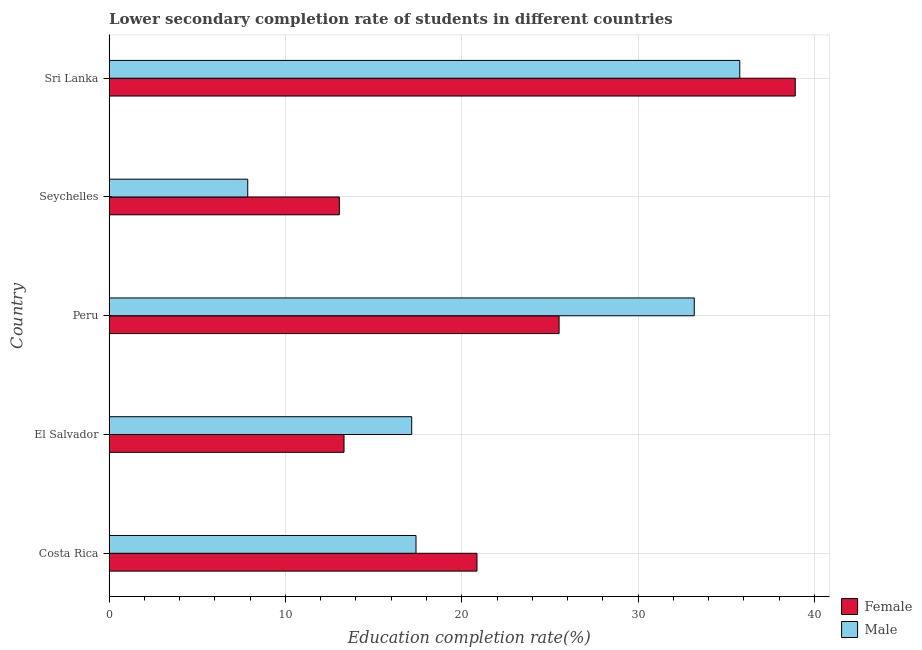How many groups of bars are there?
Your response must be concise. 5. Are the number of bars per tick equal to the number of legend labels?
Your answer should be compact. Yes. Are the number of bars on each tick of the Y-axis equal?
Offer a terse response. Yes. How many bars are there on the 3rd tick from the top?
Make the answer very short. 2. How many bars are there on the 5th tick from the bottom?
Your answer should be very brief. 2. What is the label of the 4th group of bars from the top?
Offer a terse response. El Salvador. What is the education completion rate of male students in Costa Rica?
Your answer should be very brief. 17.41. Across all countries, what is the maximum education completion rate of female students?
Offer a very short reply. 38.91. Across all countries, what is the minimum education completion rate of female students?
Ensure brevity in your answer.  13.06. In which country was the education completion rate of female students maximum?
Provide a short and direct response. Sri Lanka. In which country was the education completion rate of male students minimum?
Your response must be concise. Seychelles. What is the total education completion rate of male students in the graph?
Ensure brevity in your answer.  111.37. What is the difference between the education completion rate of male students in El Salvador and that in Seychelles?
Give a very brief answer. 9.3. What is the difference between the education completion rate of male students in Seychelles and the education completion rate of female students in Sri Lanka?
Your answer should be compact. -31.04. What is the average education completion rate of female students per country?
Keep it short and to the point. 22.33. What is the difference between the education completion rate of female students and education completion rate of male students in Peru?
Your answer should be very brief. -7.66. In how many countries, is the education completion rate of male students greater than 18 %?
Give a very brief answer. 2. What is the ratio of the education completion rate of female students in El Salvador to that in Sri Lanka?
Provide a succinct answer. 0.34. Is the education completion rate of female students in Costa Rica less than that in El Salvador?
Your answer should be very brief. No. Is the difference between the education completion rate of male students in Costa Rica and Seychelles greater than the difference between the education completion rate of female students in Costa Rica and Seychelles?
Give a very brief answer. Yes. What is the difference between the highest and the second highest education completion rate of male students?
Ensure brevity in your answer.  2.58. What is the difference between the highest and the lowest education completion rate of female students?
Keep it short and to the point. 25.85. Is the sum of the education completion rate of male students in Costa Rica and El Salvador greater than the maximum education completion rate of female students across all countries?
Ensure brevity in your answer.  No. What does the 1st bar from the top in Seychelles represents?
Provide a succinct answer. Male. What does the 1st bar from the bottom in Peru represents?
Offer a terse response. Female. How many bars are there?
Provide a short and direct response. 10. What is the difference between two consecutive major ticks on the X-axis?
Offer a terse response. 10. Does the graph contain any zero values?
Keep it short and to the point. No. How many legend labels are there?
Offer a terse response. 2. What is the title of the graph?
Provide a succinct answer. Lower secondary completion rate of students in different countries. What is the label or title of the X-axis?
Your response must be concise. Education completion rate(%). What is the Education completion rate(%) of Female in Costa Rica?
Ensure brevity in your answer.  20.86. What is the Education completion rate(%) of Male in Costa Rica?
Offer a terse response. 17.41. What is the Education completion rate(%) of Female in El Salvador?
Provide a succinct answer. 13.32. What is the Education completion rate(%) in Male in El Salvador?
Give a very brief answer. 17.16. What is the Education completion rate(%) of Female in Peru?
Offer a very short reply. 25.52. What is the Education completion rate(%) in Male in Peru?
Offer a very short reply. 33.18. What is the Education completion rate(%) in Female in Seychelles?
Provide a short and direct response. 13.06. What is the Education completion rate(%) of Male in Seychelles?
Offer a very short reply. 7.87. What is the Education completion rate(%) in Female in Sri Lanka?
Your answer should be compact. 38.91. What is the Education completion rate(%) of Male in Sri Lanka?
Keep it short and to the point. 35.76. Across all countries, what is the maximum Education completion rate(%) of Female?
Offer a very short reply. 38.91. Across all countries, what is the maximum Education completion rate(%) of Male?
Make the answer very short. 35.76. Across all countries, what is the minimum Education completion rate(%) in Female?
Keep it short and to the point. 13.06. Across all countries, what is the minimum Education completion rate(%) of Male?
Your response must be concise. 7.87. What is the total Education completion rate(%) of Female in the graph?
Your answer should be very brief. 111.67. What is the total Education completion rate(%) of Male in the graph?
Make the answer very short. 111.37. What is the difference between the Education completion rate(%) in Female in Costa Rica and that in El Salvador?
Offer a very short reply. 7.54. What is the difference between the Education completion rate(%) of Male in Costa Rica and that in El Salvador?
Ensure brevity in your answer.  0.24. What is the difference between the Education completion rate(%) in Female in Costa Rica and that in Peru?
Give a very brief answer. -4.65. What is the difference between the Education completion rate(%) in Male in Costa Rica and that in Peru?
Your answer should be compact. -15.78. What is the difference between the Education completion rate(%) in Female in Costa Rica and that in Seychelles?
Give a very brief answer. 7.8. What is the difference between the Education completion rate(%) in Male in Costa Rica and that in Seychelles?
Keep it short and to the point. 9.54. What is the difference between the Education completion rate(%) in Female in Costa Rica and that in Sri Lanka?
Your answer should be compact. -18.05. What is the difference between the Education completion rate(%) of Male in Costa Rica and that in Sri Lanka?
Provide a short and direct response. -18.35. What is the difference between the Education completion rate(%) of Female in El Salvador and that in Peru?
Keep it short and to the point. -12.19. What is the difference between the Education completion rate(%) of Male in El Salvador and that in Peru?
Offer a terse response. -16.02. What is the difference between the Education completion rate(%) of Female in El Salvador and that in Seychelles?
Give a very brief answer. 0.27. What is the difference between the Education completion rate(%) in Male in El Salvador and that in Seychelles?
Offer a very short reply. 9.3. What is the difference between the Education completion rate(%) in Female in El Salvador and that in Sri Lanka?
Your answer should be compact. -25.58. What is the difference between the Education completion rate(%) in Male in El Salvador and that in Sri Lanka?
Provide a short and direct response. -18.6. What is the difference between the Education completion rate(%) of Female in Peru and that in Seychelles?
Your answer should be compact. 12.46. What is the difference between the Education completion rate(%) of Male in Peru and that in Seychelles?
Ensure brevity in your answer.  25.32. What is the difference between the Education completion rate(%) of Female in Peru and that in Sri Lanka?
Offer a terse response. -13.39. What is the difference between the Education completion rate(%) in Male in Peru and that in Sri Lanka?
Offer a terse response. -2.58. What is the difference between the Education completion rate(%) of Female in Seychelles and that in Sri Lanka?
Your answer should be compact. -25.85. What is the difference between the Education completion rate(%) of Male in Seychelles and that in Sri Lanka?
Offer a terse response. -27.9. What is the difference between the Education completion rate(%) in Female in Costa Rica and the Education completion rate(%) in Male in El Salvador?
Keep it short and to the point. 3.7. What is the difference between the Education completion rate(%) of Female in Costa Rica and the Education completion rate(%) of Male in Peru?
Your response must be concise. -12.32. What is the difference between the Education completion rate(%) of Female in Costa Rica and the Education completion rate(%) of Male in Seychelles?
Make the answer very short. 13. What is the difference between the Education completion rate(%) in Female in Costa Rica and the Education completion rate(%) in Male in Sri Lanka?
Offer a very short reply. -14.9. What is the difference between the Education completion rate(%) of Female in El Salvador and the Education completion rate(%) of Male in Peru?
Your response must be concise. -19.86. What is the difference between the Education completion rate(%) in Female in El Salvador and the Education completion rate(%) in Male in Seychelles?
Your answer should be compact. 5.46. What is the difference between the Education completion rate(%) in Female in El Salvador and the Education completion rate(%) in Male in Sri Lanka?
Keep it short and to the point. -22.44. What is the difference between the Education completion rate(%) of Female in Peru and the Education completion rate(%) of Male in Seychelles?
Make the answer very short. 17.65. What is the difference between the Education completion rate(%) of Female in Peru and the Education completion rate(%) of Male in Sri Lanka?
Give a very brief answer. -10.24. What is the difference between the Education completion rate(%) in Female in Seychelles and the Education completion rate(%) in Male in Sri Lanka?
Your answer should be very brief. -22.7. What is the average Education completion rate(%) of Female per country?
Offer a very short reply. 22.33. What is the average Education completion rate(%) in Male per country?
Offer a very short reply. 22.27. What is the difference between the Education completion rate(%) of Female and Education completion rate(%) of Male in Costa Rica?
Your answer should be compact. 3.46. What is the difference between the Education completion rate(%) of Female and Education completion rate(%) of Male in El Salvador?
Ensure brevity in your answer.  -3.84. What is the difference between the Education completion rate(%) of Female and Education completion rate(%) of Male in Peru?
Your answer should be compact. -7.66. What is the difference between the Education completion rate(%) of Female and Education completion rate(%) of Male in Seychelles?
Ensure brevity in your answer.  5.19. What is the difference between the Education completion rate(%) of Female and Education completion rate(%) of Male in Sri Lanka?
Your response must be concise. 3.15. What is the ratio of the Education completion rate(%) in Female in Costa Rica to that in El Salvador?
Your answer should be compact. 1.57. What is the ratio of the Education completion rate(%) of Male in Costa Rica to that in El Salvador?
Offer a terse response. 1.01. What is the ratio of the Education completion rate(%) of Female in Costa Rica to that in Peru?
Provide a short and direct response. 0.82. What is the ratio of the Education completion rate(%) of Male in Costa Rica to that in Peru?
Your response must be concise. 0.52. What is the ratio of the Education completion rate(%) in Female in Costa Rica to that in Seychelles?
Your response must be concise. 1.6. What is the ratio of the Education completion rate(%) of Male in Costa Rica to that in Seychelles?
Offer a terse response. 2.21. What is the ratio of the Education completion rate(%) in Female in Costa Rica to that in Sri Lanka?
Provide a short and direct response. 0.54. What is the ratio of the Education completion rate(%) in Male in Costa Rica to that in Sri Lanka?
Offer a very short reply. 0.49. What is the ratio of the Education completion rate(%) of Female in El Salvador to that in Peru?
Ensure brevity in your answer.  0.52. What is the ratio of the Education completion rate(%) of Male in El Salvador to that in Peru?
Offer a very short reply. 0.52. What is the ratio of the Education completion rate(%) of Female in El Salvador to that in Seychelles?
Your answer should be very brief. 1.02. What is the ratio of the Education completion rate(%) in Male in El Salvador to that in Seychelles?
Your response must be concise. 2.18. What is the ratio of the Education completion rate(%) of Female in El Salvador to that in Sri Lanka?
Give a very brief answer. 0.34. What is the ratio of the Education completion rate(%) of Male in El Salvador to that in Sri Lanka?
Provide a short and direct response. 0.48. What is the ratio of the Education completion rate(%) in Female in Peru to that in Seychelles?
Your response must be concise. 1.95. What is the ratio of the Education completion rate(%) in Male in Peru to that in Seychelles?
Ensure brevity in your answer.  4.22. What is the ratio of the Education completion rate(%) in Female in Peru to that in Sri Lanka?
Offer a very short reply. 0.66. What is the ratio of the Education completion rate(%) of Male in Peru to that in Sri Lanka?
Your response must be concise. 0.93. What is the ratio of the Education completion rate(%) of Female in Seychelles to that in Sri Lanka?
Provide a short and direct response. 0.34. What is the ratio of the Education completion rate(%) of Male in Seychelles to that in Sri Lanka?
Provide a succinct answer. 0.22. What is the difference between the highest and the second highest Education completion rate(%) in Female?
Provide a short and direct response. 13.39. What is the difference between the highest and the second highest Education completion rate(%) in Male?
Provide a short and direct response. 2.58. What is the difference between the highest and the lowest Education completion rate(%) in Female?
Your answer should be very brief. 25.85. What is the difference between the highest and the lowest Education completion rate(%) of Male?
Your response must be concise. 27.9. 